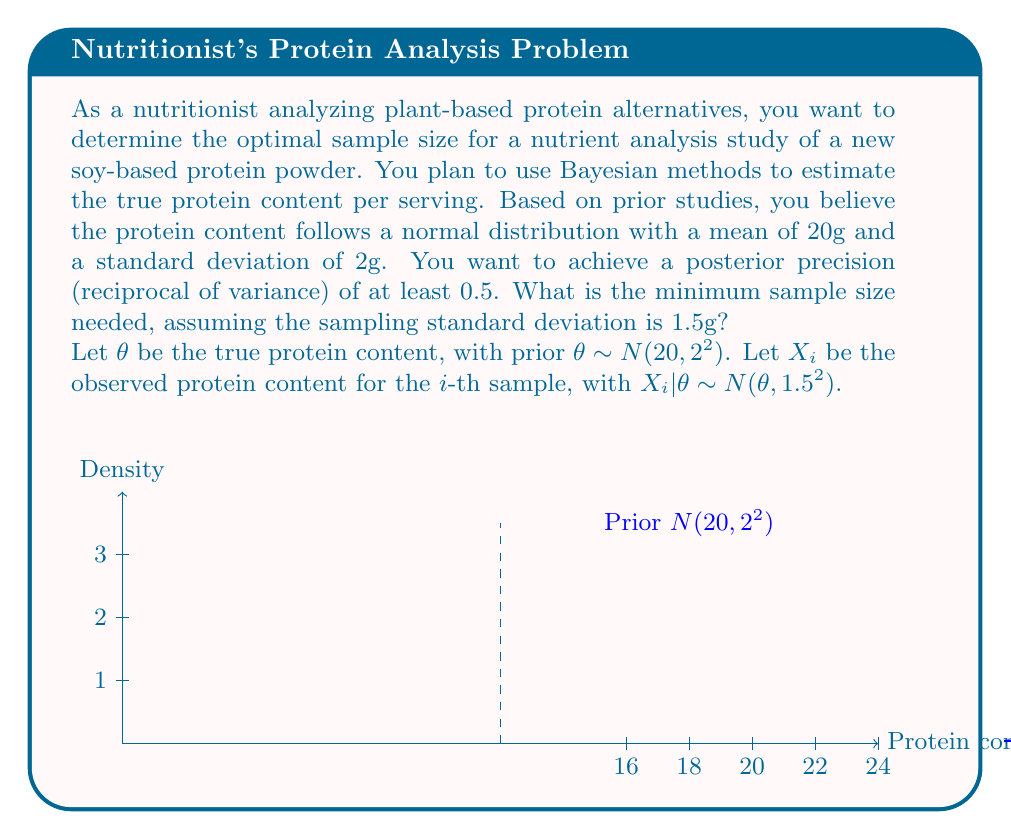Show me your answer to this math problem. To solve this problem, we'll use the properties of conjugate priors in Bayesian analysis. For a normal likelihood with known variance, the normal prior is conjugate.

1) The prior precision is:
   $$\tau_0 = \frac{1}{\sigma_0^2} = \frac{1}{2^2} = 0.25$$

2) The likelihood precision for each sample is:
   $$\tau = \frac{1}{\sigma^2} = \frac{1}{1.5^2} = \frac{4}{9} \approx 0.444$$

3) For n samples, the posterior precision is:
   $$\tau_n = \tau_0 + n\tau$$

4) We want the posterior precision to be at least 0.5, so:
   $$0.5 \leq \tau_0 + n\tau$$

5) Solving for n:
   $$0.5 \leq 0.25 + n(\frac{4}{9})$$
   $$0.25 \leq n(\frac{4}{9})$$
   $$n \geq \frac{0.25 * 9}{4} = \frac{9}{16} = 0.5625$$

6) Since n must be a whole number, we round up to the nearest integer.

Therefore, the minimum sample size needed is 1.
Answer: 1 sample 